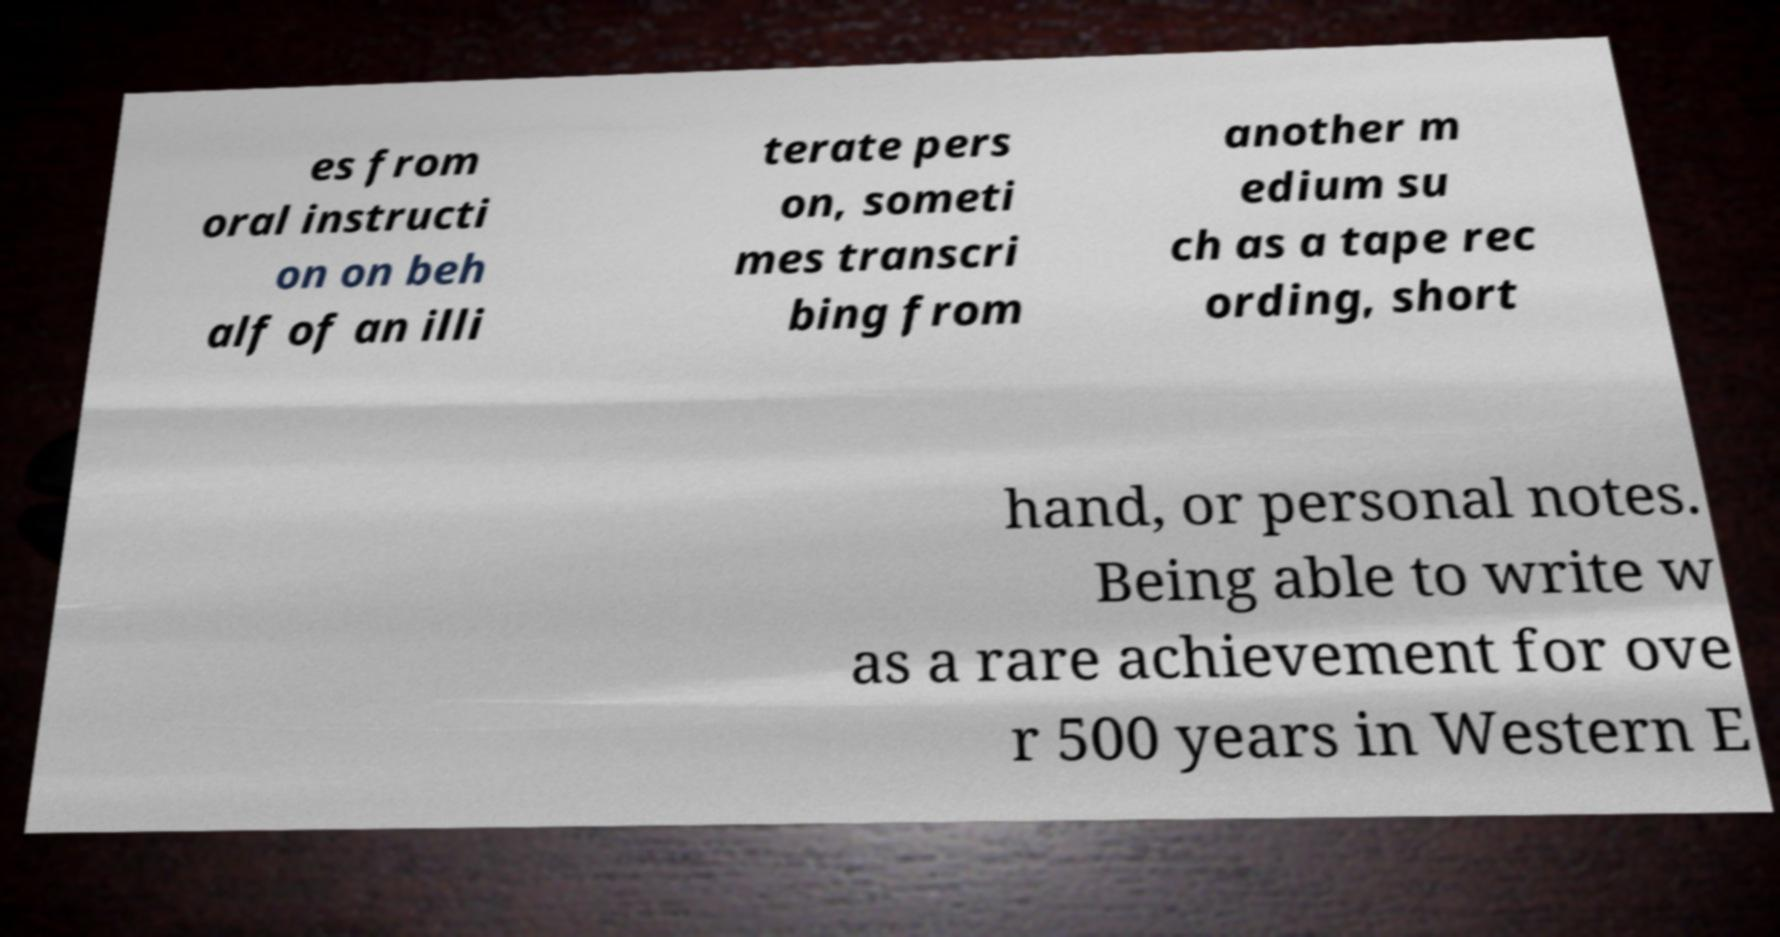There's text embedded in this image that I need extracted. Can you transcribe it verbatim? es from oral instructi on on beh alf of an illi terate pers on, someti mes transcri bing from another m edium su ch as a tape rec ording, short hand, or personal notes. Being able to write w as a rare achievement for ove r 500 years in Western E 